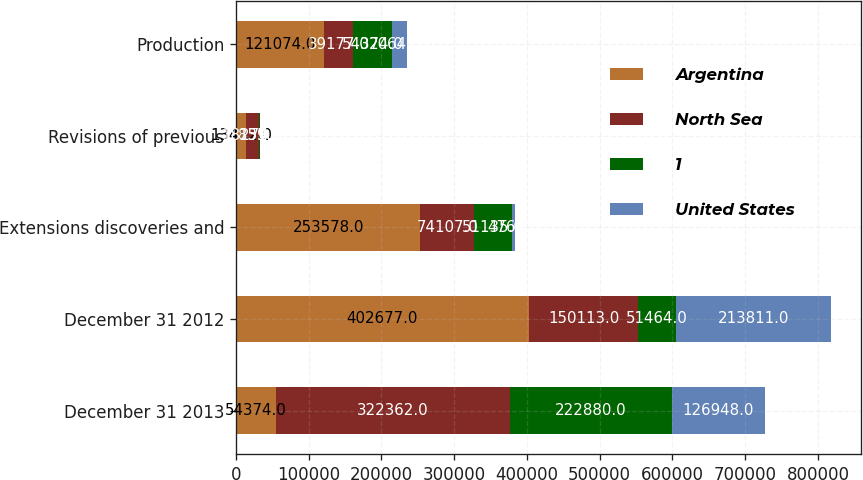Convert chart. <chart><loc_0><loc_0><loc_500><loc_500><stacked_bar_chart><ecel><fcel>December 31 2013<fcel>December 31 2012<fcel>Extensions discoveries and<fcel>Revisions of previous<fcel>Production<nl><fcel>Argentina<fcel>54374<fcel>402677<fcel>253578<fcel>13482<fcel>121074<nl><fcel>North Sea<fcel>322362<fcel>150113<fcel>74107<fcel>18274<fcel>39177<nl><fcel>1<fcel>222880<fcel>51464<fcel>51135<fcel>859<fcel>54374<nl><fcel>United States<fcel>126948<fcel>213811<fcel>4764<fcel>135<fcel>20647<nl></chart> 